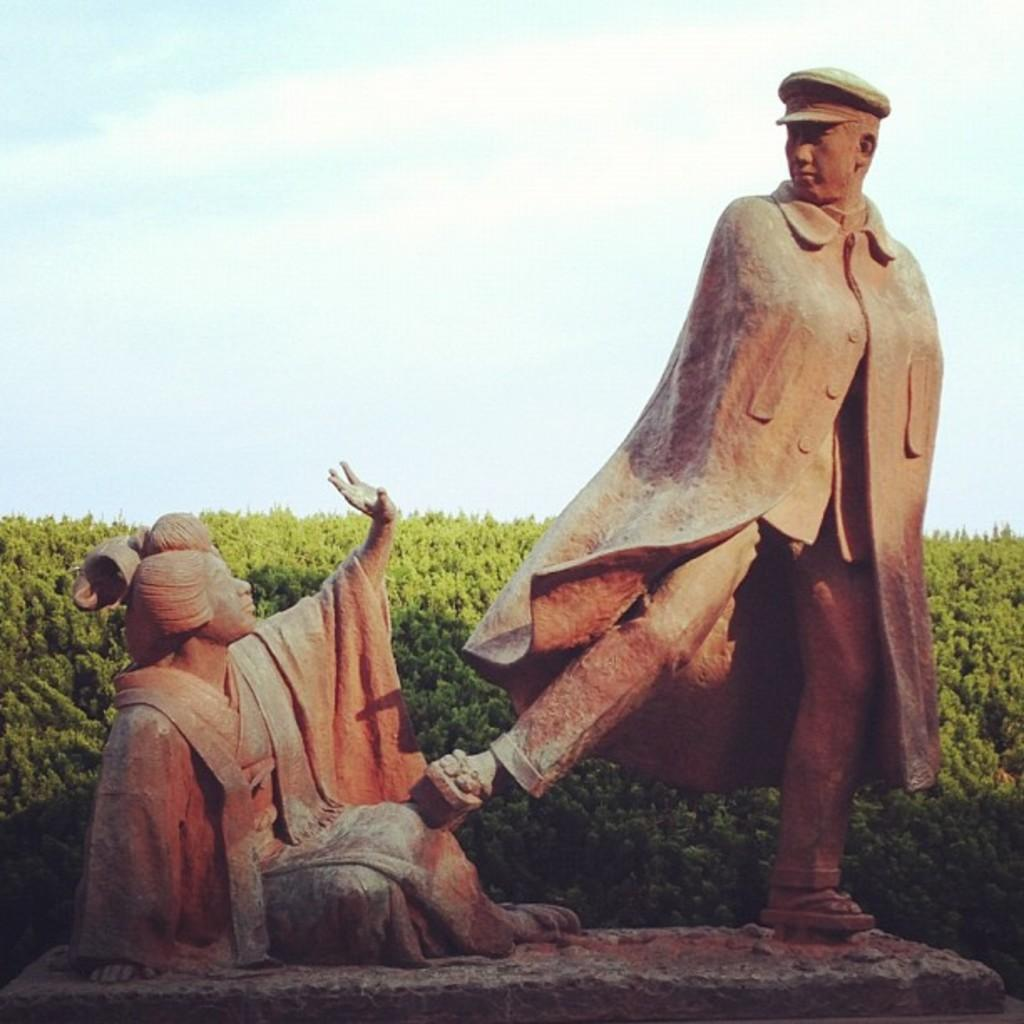What type of objects can be seen in the image? There are statues in the image. What other elements can be found in the image? There are trees in the image. What can be seen in the background of the image? The sky is visible in the image. What is the condition of the sky in the image? Clouds are present in the sky. What type of expert can be seen in the image? There is no expert present in the image. 